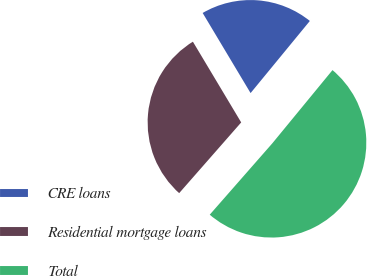Convert chart to OTSL. <chart><loc_0><loc_0><loc_500><loc_500><pie_chart><fcel>CRE loans<fcel>Residential mortgage loans<fcel>Total<nl><fcel>19.53%<fcel>29.96%<fcel>50.51%<nl></chart> 